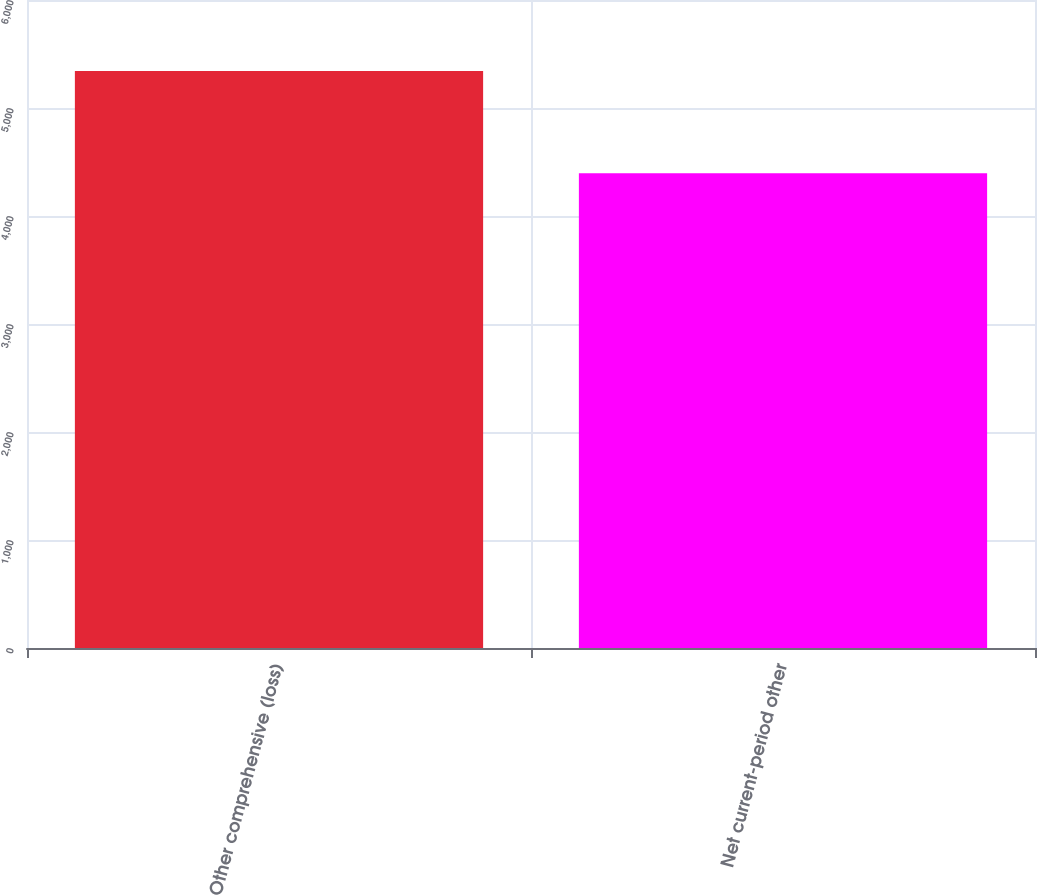Convert chart to OTSL. <chart><loc_0><loc_0><loc_500><loc_500><bar_chart><fcel>Other comprehensive (loss)<fcel>Net current-period other<nl><fcel>5342<fcel>4396<nl></chart> 